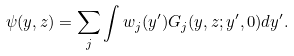<formula> <loc_0><loc_0><loc_500><loc_500>\psi ( y , z ) = \sum _ { j } \int w _ { j } ( y ^ { \prime } ) G _ { j } ( y , z ; y ^ { \prime } , 0 ) d y ^ { \prime } .</formula> 